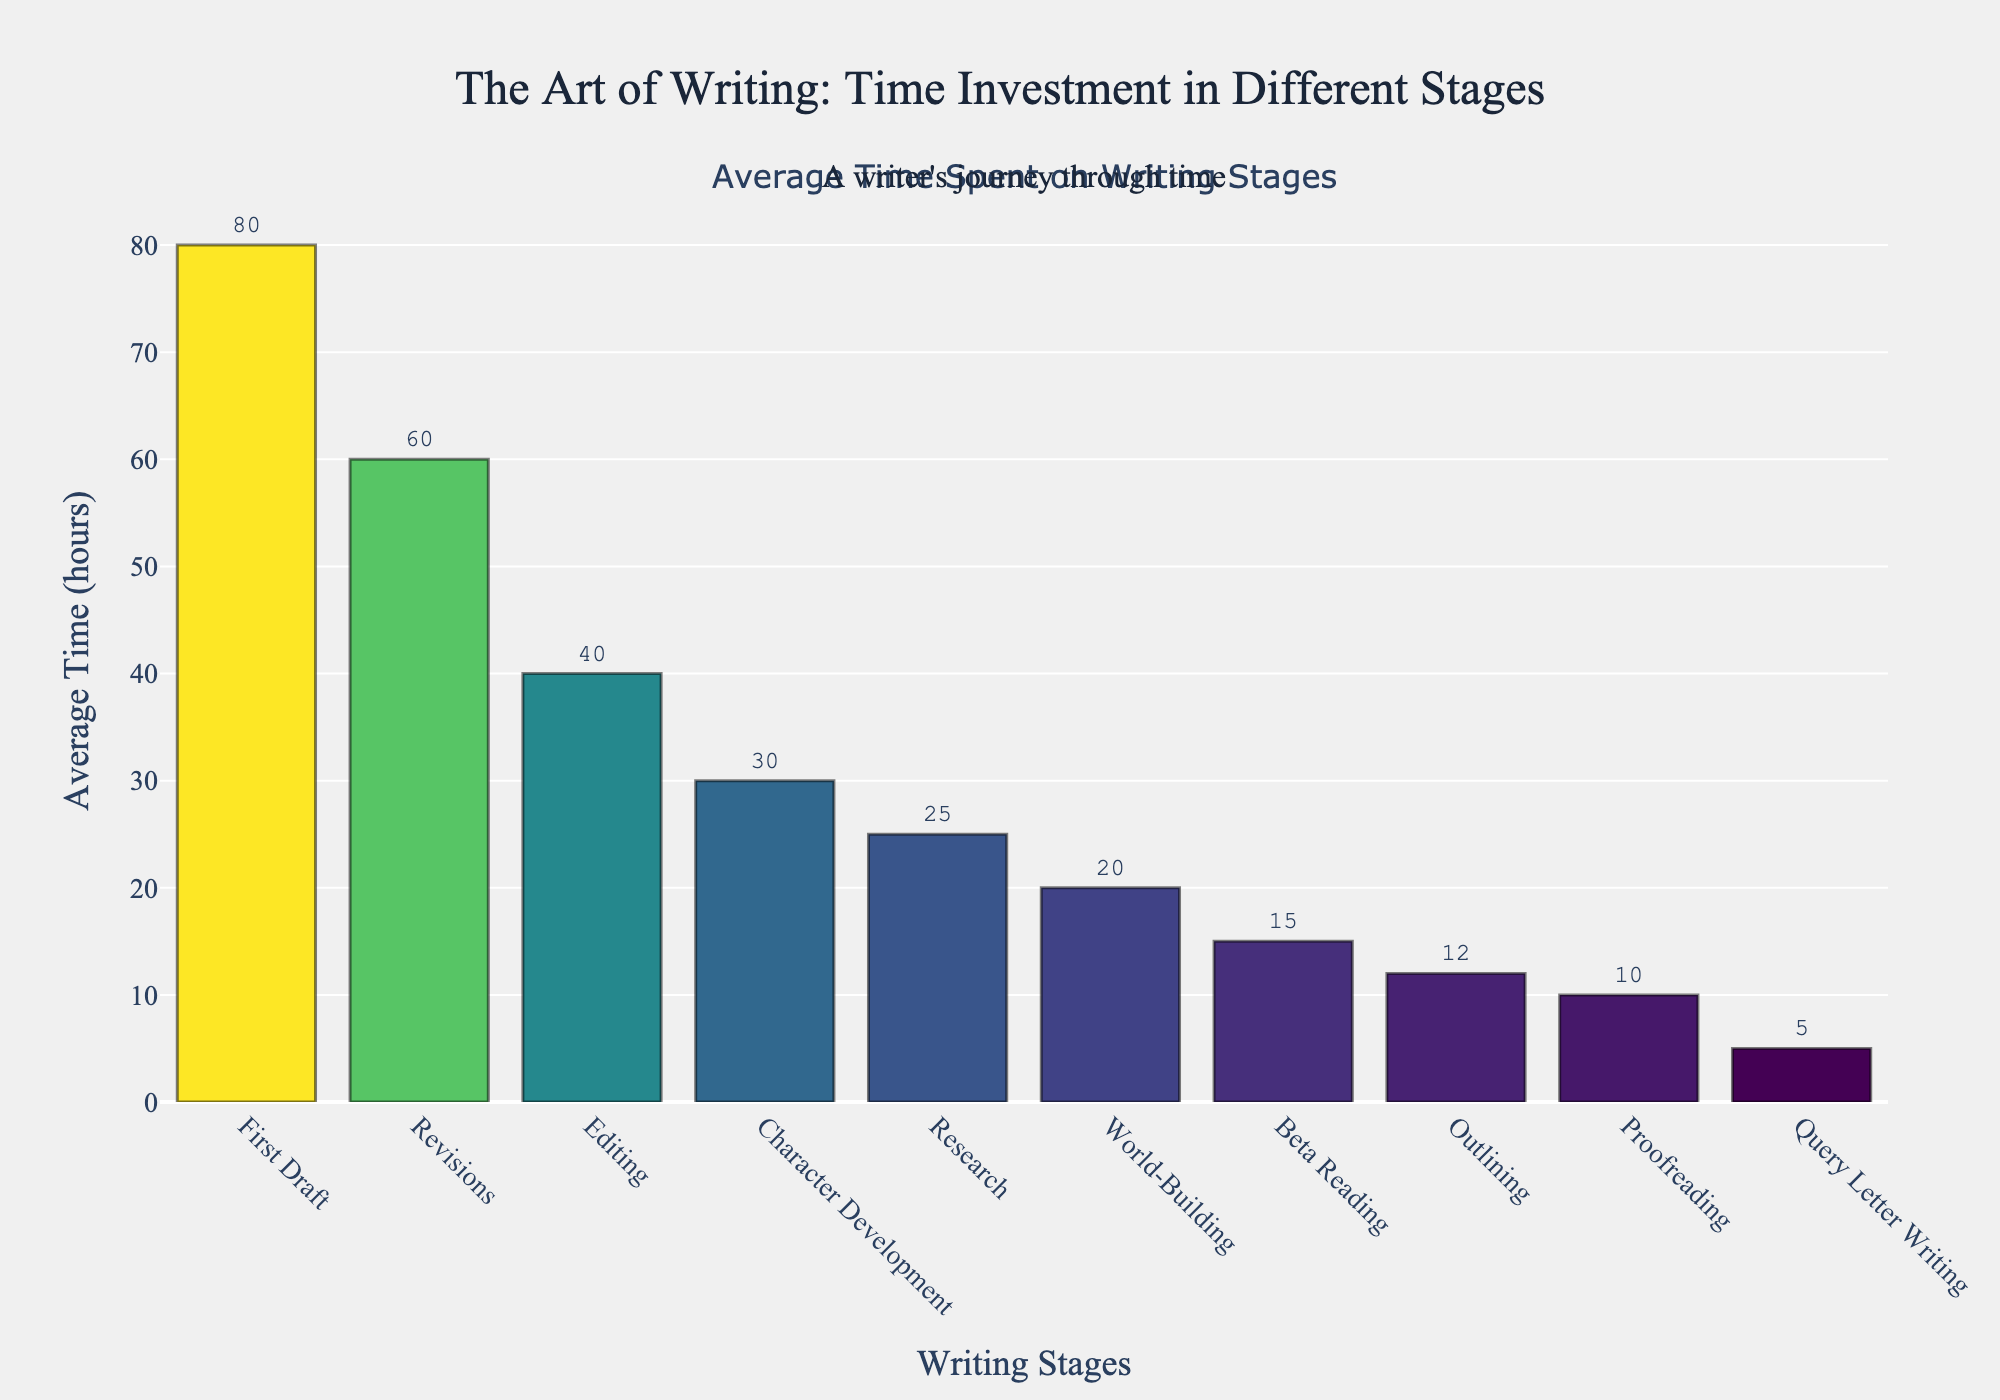What is the total time spent on Revisions and Editing combined? Sum the time spent on Revisions (60 hours) and Editing (40 hours). Total time = 60 hours + 40 hours = 100 hours
Answer: 100 hours Which stage requires the most time investment? Identify the highest bar in the figure, which corresponds to the stage with the highest average time. The highest bar represents the First Draft stage with 80 hours
Answer: First Draft How much more time on average is spent on Research compared to Proofreading? Subtract the average time spent on Proofreading (10 hours) from the average time spent on Research (25 hours). Difference = 25 hours - 10 hours = 15 hours
Answer: 15 hours Rank the top three stages with the highest average time investment Sort the stages based on the height of the bars from highest to lowest. The top three stages are: First Draft (80 hours), Revisions (60 hours), and Editing (40 hours)
Answer: First Draft, Revisions, Editing Is more time spent on World-Building or Beta Reading? By how much? Compare the average time spent on World-Building (20 hours) and Beta Reading (15 hours). Since 20 > 15, more time is spent on World-Building. Difference = 20 hours - 15 hours = 5 hours
Answer: World-Building, 5 hours Which stages have an average time of 20 hours or more? Identify the bars with average times of 20 hours or more: Research (25 hours), First Draft (80 hours), Character Development (30 hours), World-Building (20 hours), Revisions (60 hours), Editing (40 hours)
Answer: Research, First Draft, Character Development, World-Building, Revisions, Editing What is the total time spent on all stages combined? Sum the average time spent on each stage: 12 + 25 + 80 + 30 + 20 + 60 + 15 + 40 + 10 + 5 = 297 hours
Answer: 297 hours What is the average time spent on Outlining, Character Development, and Proofreading? Sum the time spent on Outlining (12 hours), Character Development (30 hours), and Proofreading (10 hours), then divide by 3. Total time = 12 + 30 + 10 = 52 hours; Average = 52 / 3 ≈ 17.33 hours
Answer: 17.33 hours 